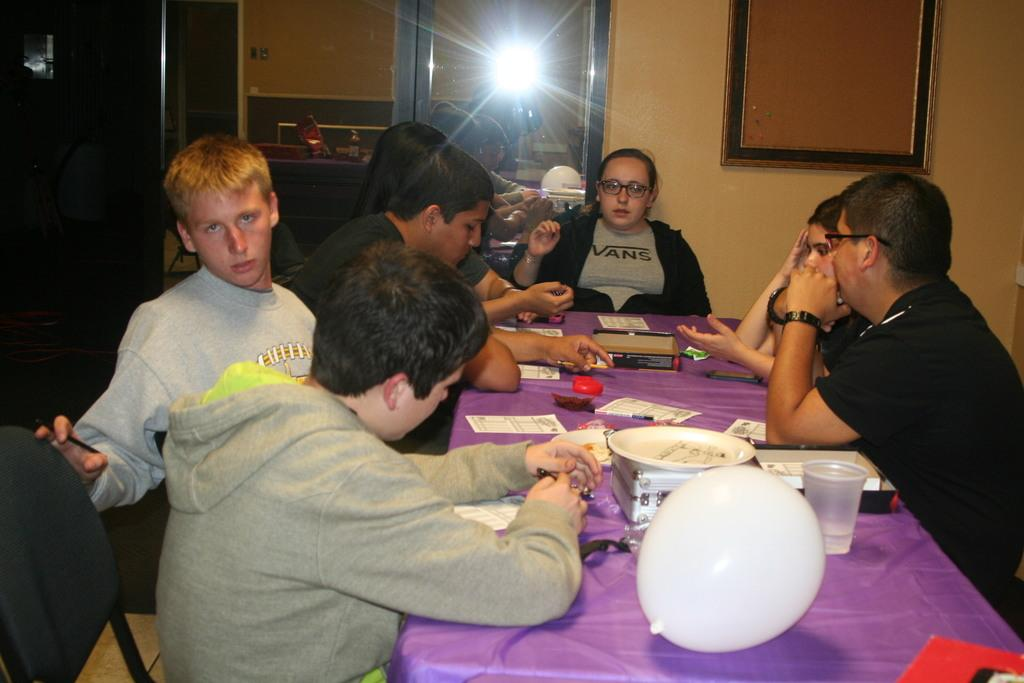What are the people in the image doing? The people in the image are sitting on chairs. What is present in the image besides the people? There is a table in the image. What can be seen on the table? There is a balloon, a glass, and snacks on a plate on the table. What type of shop can be seen in the image? There is no shop present in the image. How many months are visible in the image? There are no months visible in the image, as it is a still image and not a calendar. 